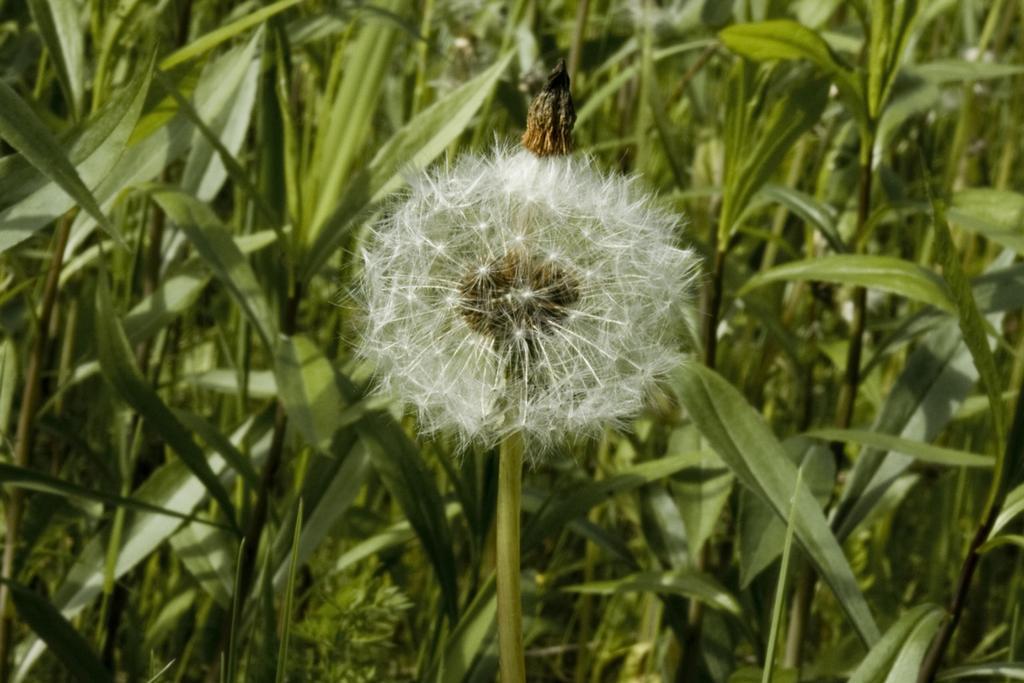Please provide a concise description of this image. In the picture there is a white flower to the plant,behind that there are many other plants with long leaves. 